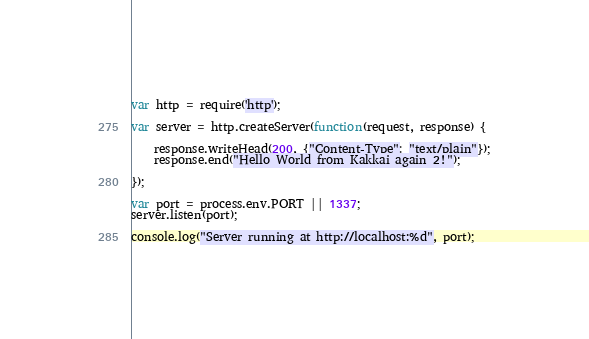Convert code to text. <code><loc_0><loc_0><loc_500><loc_500><_JavaScript_>var http = require('http');

var server = http.createServer(function(request, response) {

    response.writeHead(200, {"Content-Type": "text/plain"});
    response.end("Hello World from Kakkai again 2!");

});

var port = process.env.PORT || 1337;
server.listen(port);

console.log("Server running at http://localhost:%d", port);
</code> 